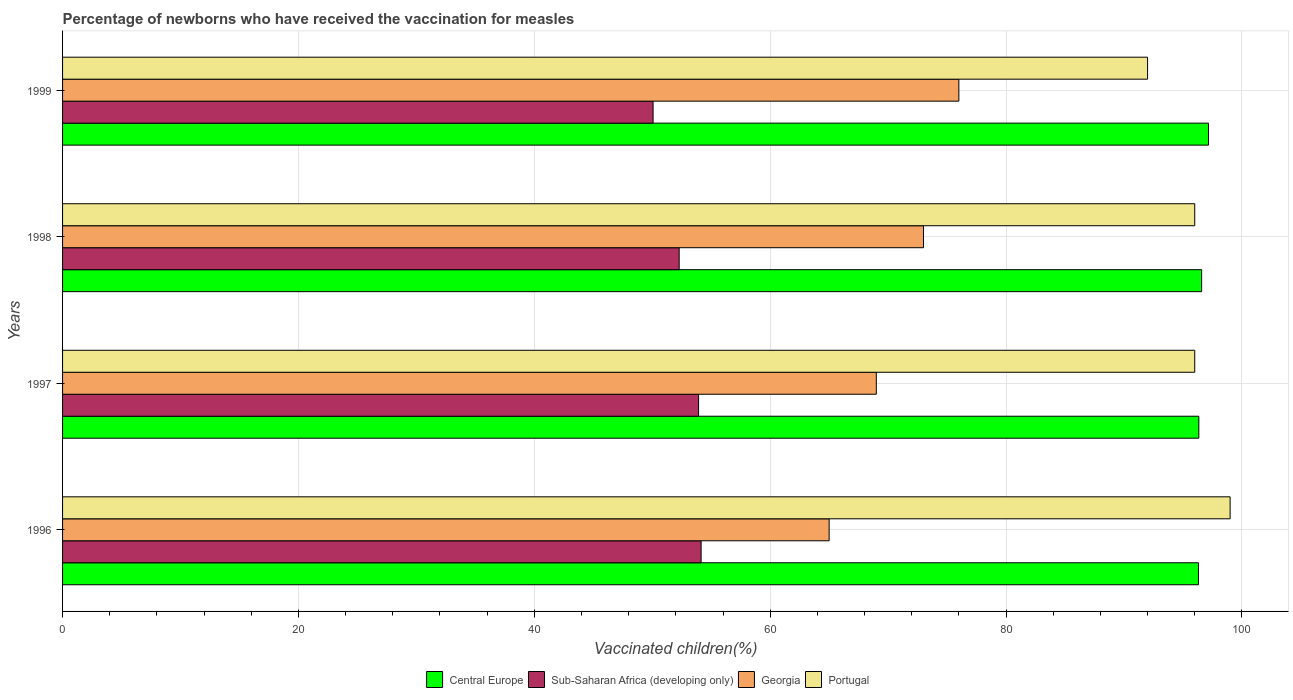How many different coloured bars are there?
Ensure brevity in your answer.  4. How many groups of bars are there?
Ensure brevity in your answer.  4. Are the number of bars on each tick of the Y-axis equal?
Offer a very short reply. Yes. What is the label of the 2nd group of bars from the top?
Your response must be concise. 1998. In how many cases, is the number of bars for a given year not equal to the number of legend labels?
Provide a succinct answer. 0. What is the percentage of vaccinated children in Portugal in 1996?
Give a very brief answer. 99. Across all years, what is the maximum percentage of vaccinated children in Sub-Saharan Africa (developing only)?
Provide a succinct answer. 54.14. Across all years, what is the minimum percentage of vaccinated children in Sub-Saharan Africa (developing only)?
Provide a succinct answer. 50.07. In which year was the percentage of vaccinated children in Sub-Saharan Africa (developing only) maximum?
Provide a succinct answer. 1996. In which year was the percentage of vaccinated children in Central Europe minimum?
Ensure brevity in your answer.  1996. What is the total percentage of vaccinated children in Sub-Saharan Africa (developing only) in the graph?
Offer a terse response. 210.43. What is the difference between the percentage of vaccinated children in Sub-Saharan Africa (developing only) in 1996 and that in 1998?
Provide a short and direct response. 1.86. What is the difference between the percentage of vaccinated children in Sub-Saharan Africa (developing only) in 1996 and the percentage of vaccinated children in Central Europe in 1998?
Your response must be concise. -42.44. What is the average percentage of vaccinated children in Central Europe per year?
Give a very brief answer. 96.6. In the year 1998, what is the difference between the percentage of vaccinated children in Georgia and percentage of vaccinated children in Portugal?
Your answer should be compact. -23. In how many years, is the percentage of vaccinated children in Georgia greater than 76 %?
Offer a very short reply. 0. What is the ratio of the percentage of vaccinated children in Central Europe in 1998 to that in 1999?
Provide a short and direct response. 0.99. Is the difference between the percentage of vaccinated children in Georgia in 1996 and 1998 greater than the difference between the percentage of vaccinated children in Portugal in 1996 and 1998?
Offer a terse response. No. What is the difference between the highest and the lowest percentage of vaccinated children in Portugal?
Ensure brevity in your answer.  7. In how many years, is the percentage of vaccinated children in Portugal greater than the average percentage of vaccinated children in Portugal taken over all years?
Your response must be concise. 3. Is it the case that in every year, the sum of the percentage of vaccinated children in Portugal and percentage of vaccinated children in Sub-Saharan Africa (developing only) is greater than the percentage of vaccinated children in Georgia?
Give a very brief answer. Yes. What is the difference between two consecutive major ticks on the X-axis?
Your answer should be very brief. 20. Are the values on the major ticks of X-axis written in scientific E-notation?
Provide a short and direct response. No. Does the graph contain any zero values?
Keep it short and to the point. No. Does the graph contain grids?
Make the answer very short. Yes. What is the title of the graph?
Offer a very short reply. Percentage of newborns who have received the vaccination for measles. Does "Seychelles" appear as one of the legend labels in the graph?
Ensure brevity in your answer.  No. What is the label or title of the X-axis?
Ensure brevity in your answer.  Vaccinated children(%). What is the label or title of the Y-axis?
Your response must be concise. Years. What is the Vaccinated children(%) of Central Europe in 1996?
Keep it short and to the point. 96.32. What is the Vaccinated children(%) of Sub-Saharan Africa (developing only) in 1996?
Your response must be concise. 54.14. What is the Vaccinated children(%) in Georgia in 1996?
Make the answer very short. 65. What is the Vaccinated children(%) of Central Europe in 1997?
Make the answer very short. 96.35. What is the Vaccinated children(%) in Sub-Saharan Africa (developing only) in 1997?
Keep it short and to the point. 53.93. What is the Vaccinated children(%) in Portugal in 1997?
Ensure brevity in your answer.  96. What is the Vaccinated children(%) of Central Europe in 1998?
Keep it short and to the point. 96.58. What is the Vaccinated children(%) of Sub-Saharan Africa (developing only) in 1998?
Ensure brevity in your answer.  52.28. What is the Vaccinated children(%) in Portugal in 1998?
Your response must be concise. 96. What is the Vaccinated children(%) in Central Europe in 1999?
Keep it short and to the point. 97.17. What is the Vaccinated children(%) in Sub-Saharan Africa (developing only) in 1999?
Keep it short and to the point. 50.07. What is the Vaccinated children(%) of Georgia in 1999?
Your answer should be very brief. 76. What is the Vaccinated children(%) of Portugal in 1999?
Make the answer very short. 92. Across all years, what is the maximum Vaccinated children(%) in Central Europe?
Provide a short and direct response. 97.17. Across all years, what is the maximum Vaccinated children(%) in Sub-Saharan Africa (developing only)?
Your answer should be very brief. 54.14. Across all years, what is the maximum Vaccinated children(%) in Georgia?
Your response must be concise. 76. Across all years, what is the maximum Vaccinated children(%) of Portugal?
Your answer should be compact. 99. Across all years, what is the minimum Vaccinated children(%) of Central Europe?
Provide a short and direct response. 96.32. Across all years, what is the minimum Vaccinated children(%) of Sub-Saharan Africa (developing only)?
Your response must be concise. 50.07. Across all years, what is the minimum Vaccinated children(%) in Portugal?
Make the answer very short. 92. What is the total Vaccinated children(%) in Central Europe in the graph?
Give a very brief answer. 386.41. What is the total Vaccinated children(%) in Sub-Saharan Africa (developing only) in the graph?
Offer a terse response. 210.43. What is the total Vaccinated children(%) in Georgia in the graph?
Offer a very short reply. 283. What is the total Vaccinated children(%) in Portugal in the graph?
Offer a very short reply. 383. What is the difference between the Vaccinated children(%) in Central Europe in 1996 and that in 1997?
Provide a short and direct response. -0.03. What is the difference between the Vaccinated children(%) of Sub-Saharan Africa (developing only) in 1996 and that in 1997?
Make the answer very short. 0.21. What is the difference between the Vaccinated children(%) in Central Europe in 1996 and that in 1998?
Make the answer very short. -0.27. What is the difference between the Vaccinated children(%) in Sub-Saharan Africa (developing only) in 1996 and that in 1998?
Offer a very short reply. 1.86. What is the difference between the Vaccinated children(%) in Georgia in 1996 and that in 1998?
Offer a very short reply. -8. What is the difference between the Vaccinated children(%) of Portugal in 1996 and that in 1998?
Give a very brief answer. 3. What is the difference between the Vaccinated children(%) in Central Europe in 1996 and that in 1999?
Make the answer very short. -0.85. What is the difference between the Vaccinated children(%) in Sub-Saharan Africa (developing only) in 1996 and that in 1999?
Keep it short and to the point. 4.07. What is the difference between the Vaccinated children(%) in Georgia in 1996 and that in 1999?
Provide a succinct answer. -11. What is the difference between the Vaccinated children(%) of Portugal in 1996 and that in 1999?
Offer a very short reply. 7. What is the difference between the Vaccinated children(%) of Central Europe in 1997 and that in 1998?
Give a very brief answer. -0.24. What is the difference between the Vaccinated children(%) of Sub-Saharan Africa (developing only) in 1997 and that in 1998?
Your response must be concise. 1.64. What is the difference between the Vaccinated children(%) of Central Europe in 1997 and that in 1999?
Ensure brevity in your answer.  -0.82. What is the difference between the Vaccinated children(%) in Sub-Saharan Africa (developing only) in 1997 and that in 1999?
Your answer should be very brief. 3.86. What is the difference between the Vaccinated children(%) in Central Europe in 1998 and that in 1999?
Make the answer very short. -0.58. What is the difference between the Vaccinated children(%) in Sub-Saharan Africa (developing only) in 1998 and that in 1999?
Ensure brevity in your answer.  2.21. What is the difference between the Vaccinated children(%) in Portugal in 1998 and that in 1999?
Provide a succinct answer. 4. What is the difference between the Vaccinated children(%) in Central Europe in 1996 and the Vaccinated children(%) in Sub-Saharan Africa (developing only) in 1997?
Give a very brief answer. 42.39. What is the difference between the Vaccinated children(%) of Central Europe in 1996 and the Vaccinated children(%) of Georgia in 1997?
Offer a very short reply. 27.32. What is the difference between the Vaccinated children(%) of Central Europe in 1996 and the Vaccinated children(%) of Portugal in 1997?
Provide a succinct answer. 0.32. What is the difference between the Vaccinated children(%) in Sub-Saharan Africa (developing only) in 1996 and the Vaccinated children(%) in Georgia in 1997?
Offer a very short reply. -14.86. What is the difference between the Vaccinated children(%) in Sub-Saharan Africa (developing only) in 1996 and the Vaccinated children(%) in Portugal in 1997?
Make the answer very short. -41.86. What is the difference between the Vaccinated children(%) in Georgia in 1996 and the Vaccinated children(%) in Portugal in 1997?
Give a very brief answer. -31. What is the difference between the Vaccinated children(%) in Central Europe in 1996 and the Vaccinated children(%) in Sub-Saharan Africa (developing only) in 1998?
Your answer should be very brief. 44.03. What is the difference between the Vaccinated children(%) in Central Europe in 1996 and the Vaccinated children(%) in Georgia in 1998?
Your answer should be very brief. 23.32. What is the difference between the Vaccinated children(%) of Central Europe in 1996 and the Vaccinated children(%) of Portugal in 1998?
Make the answer very short. 0.32. What is the difference between the Vaccinated children(%) of Sub-Saharan Africa (developing only) in 1996 and the Vaccinated children(%) of Georgia in 1998?
Offer a terse response. -18.86. What is the difference between the Vaccinated children(%) of Sub-Saharan Africa (developing only) in 1996 and the Vaccinated children(%) of Portugal in 1998?
Offer a very short reply. -41.86. What is the difference between the Vaccinated children(%) of Georgia in 1996 and the Vaccinated children(%) of Portugal in 1998?
Make the answer very short. -31. What is the difference between the Vaccinated children(%) in Central Europe in 1996 and the Vaccinated children(%) in Sub-Saharan Africa (developing only) in 1999?
Offer a terse response. 46.24. What is the difference between the Vaccinated children(%) of Central Europe in 1996 and the Vaccinated children(%) of Georgia in 1999?
Make the answer very short. 20.32. What is the difference between the Vaccinated children(%) in Central Europe in 1996 and the Vaccinated children(%) in Portugal in 1999?
Offer a terse response. 4.32. What is the difference between the Vaccinated children(%) of Sub-Saharan Africa (developing only) in 1996 and the Vaccinated children(%) of Georgia in 1999?
Provide a succinct answer. -21.86. What is the difference between the Vaccinated children(%) of Sub-Saharan Africa (developing only) in 1996 and the Vaccinated children(%) of Portugal in 1999?
Provide a short and direct response. -37.86. What is the difference between the Vaccinated children(%) in Central Europe in 1997 and the Vaccinated children(%) in Sub-Saharan Africa (developing only) in 1998?
Your response must be concise. 44.06. What is the difference between the Vaccinated children(%) in Central Europe in 1997 and the Vaccinated children(%) in Georgia in 1998?
Your response must be concise. 23.35. What is the difference between the Vaccinated children(%) in Central Europe in 1997 and the Vaccinated children(%) in Portugal in 1998?
Offer a terse response. 0.35. What is the difference between the Vaccinated children(%) in Sub-Saharan Africa (developing only) in 1997 and the Vaccinated children(%) in Georgia in 1998?
Offer a terse response. -19.07. What is the difference between the Vaccinated children(%) of Sub-Saharan Africa (developing only) in 1997 and the Vaccinated children(%) of Portugal in 1998?
Provide a short and direct response. -42.07. What is the difference between the Vaccinated children(%) of Central Europe in 1997 and the Vaccinated children(%) of Sub-Saharan Africa (developing only) in 1999?
Your answer should be very brief. 46.27. What is the difference between the Vaccinated children(%) of Central Europe in 1997 and the Vaccinated children(%) of Georgia in 1999?
Provide a succinct answer. 20.35. What is the difference between the Vaccinated children(%) of Central Europe in 1997 and the Vaccinated children(%) of Portugal in 1999?
Provide a succinct answer. 4.35. What is the difference between the Vaccinated children(%) of Sub-Saharan Africa (developing only) in 1997 and the Vaccinated children(%) of Georgia in 1999?
Your response must be concise. -22.07. What is the difference between the Vaccinated children(%) of Sub-Saharan Africa (developing only) in 1997 and the Vaccinated children(%) of Portugal in 1999?
Provide a succinct answer. -38.07. What is the difference between the Vaccinated children(%) in Central Europe in 1998 and the Vaccinated children(%) in Sub-Saharan Africa (developing only) in 1999?
Provide a succinct answer. 46.51. What is the difference between the Vaccinated children(%) in Central Europe in 1998 and the Vaccinated children(%) in Georgia in 1999?
Provide a succinct answer. 20.58. What is the difference between the Vaccinated children(%) of Central Europe in 1998 and the Vaccinated children(%) of Portugal in 1999?
Ensure brevity in your answer.  4.58. What is the difference between the Vaccinated children(%) in Sub-Saharan Africa (developing only) in 1998 and the Vaccinated children(%) in Georgia in 1999?
Your answer should be very brief. -23.72. What is the difference between the Vaccinated children(%) in Sub-Saharan Africa (developing only) in 1998 and the Vaccinated children(%) in Portugal in 1999?
Provide a succinct answer. -39.72. What is the average Vaccinated children(%) in Central Europe per year?
Your response must be concise. 96.6. What is the average Vaccinated children(%) in Sub-Saharan Africa (developing only) per year?
Your response must be concise. 52.61. What is the average Vaccinated children(%) of Georgia per year?
Provide a short and direct response. 70.75. What is the average Vaccinated children(%) in Portugal per year?
Offer a terse response. 95.75. In the year 1996, what is the difference between the Vaccinated children(%) in Central Europe and Vaccinated children(%) in Sub-Saharan Africa (developing only)?
Give a very brief answer. 42.17. In the year 1996, what is the difference between the Vaccinated children(%) of Central Europe and Vaccinated children(%) of Georgia?
Your response must be concise. 31.32. In the year 1996, what is the difference between the Vaccinated children(%) in Central Europe and Vaccinated children(%) in Portugal?
Provide a short and direct response. -2.68. In the year 1996, what is the difference between the Vaccinated children(%) of Sub-Saharan Africa (developing only) and Vaccinated children(%) of Georgia?
Provide a short and direct response. -10.86. In the year 1996, what is the difference between the Vaccinated children(%) of Sub-Saharan Africa (developing only) and Vaccinated children(%) of Portugal?
Make the answer very short. -44.86. In the year 1996, what is the difference between the Vaccinated children(%) of Georgia and Vaccinated children(%) of Portugal?
Your response must be concise. -34. In the year 1997, what is the difference between the Vaccinated children(%) in Central Europe and Vaccinated children(%) in Sub-Saharan Africa (developing only)?
Offer a terse response. 42.42. In the year 1997, what is the difference between the Vaccinated children(%) of Central Europe and Vaccinated children(%) of Georgia?
Keep it short and to the point. 27.35. In the year 1997, what is the difference between the Vaccinated children(%) in Central Europe and Vaccinated children(%) in Portugal?
Make the answer very short. 0.35. In the year 1997, what is the difference between the Vaccinated children(%) of Sub-Saharan Africa (developing only) and Vaccinated children(%) of Georgia?
Your answer should be compact. -15.07. In the year 1997, what is the difference between the Vaccinated children(%) of Sub-Saharan Africa (developing only) and Vaccinated children(%) of Portugal?
Provide a succinct answer. -42.07. In the year 1998, what is the difference between the Vaccinated children(%) in Central Europe and Vaccinated children(%) in Sub-Saharan Africa (developing only)?
Provide a short and direct response. 44.3. In the year 1998, what is the difference between the Vaccinated children(%) of Central Europe and Vaccinated children(%) of Georgia?
Your response must be concise. 23.58. In the year 1998, what is the difference between the Vaccinated children(%) in Central Europe and Vaccinated children(%) in Portugal?
Give a very brief answer. 0.58. In the year 1998, what is the difference between the Vaccinated children(%) of Sub-Saharan Africa (developing only) and Vaccinated children(%) of Georgia?
Provide a short and direct response. -20.72. In the year 1998, what is the difference between the Vaccinated children(%) of Sub-Saharan Africa (developing only) and Vaccinated children(%) of Portugal?
Your answer should be very brief. -43.72. In the year 1998, what is the difference between the Vaccinated children(%) of Georgia and Vaccinated children(%) of Portugal?
Ensure brevity in your answer.  -23. In the year 1999, what is the difference between the Vaccinated children(%) in Central Europe and Vaccinated children(%) in Sub-Saharan Africa (developing only)?
Provide a succinct answer. 47.09. In the year 1999, what is the difference between the Vaccinated children(%) of Central Europe and Vaccinated children(%) of Georgia?
Offer a very short reply. 21.17. In the year 1999, what is the difference between the Vaccinated children(%) in Central Europe and Vaccinated children(%) in Portugal?
Make the answer very short. 5.17. In the year 1999, what is the difference between the Vaccinated children(%) in Sub-Saharan Africa (developing only) and Vaccinated children(%) in Georgia?
Your response must be concise. -25.93. In the year 1999, what is the difference between the Vaccinated children(%) in Sub-Saharan Africa (developing only) and Vaccinated children(%) in Portugal?
Your response must be concise. -41.93. What is the ratio of the Vaccinated children(%) in Sub-Saharan Africa (developing only) in 1996 to that in 1997?
Offer a very short reply. 1. What is the ratio of the Vaccinated children(%) of Georgia in 1996 to that in 1997?
Your response must be concise. 0.94. What is the ratio of the Vaccinated children(%) in Portugal in 1996 to that in 1997?
Keep it short and to the point. 1.03. What is the ratio of the Vaccinated children(%) in Sub-Saharan Africa (developing only) in 1996 to that in 1998?
Give a very brief answer. 1.04. What is the ratio of the Vaccinated children(%) of Georgia in 1996 to that in 1998?
Ensure brevity in your answer.  0.89. What is the ratio of the Vaccinated children(%) in Portugal in 1996 to that in 1998?
Your answer should be compact. 1.03. What is the ratio of the Vaccinated children(%) in Sub-Saharan Africa (developing only) in 1996 to that in 1999?
Your answer should be very brief. 1.08. What is the ratio of the Vaccinated children(%) in Georgia in 1996 to that in 1999?
Keep it short and to the point. 0.86. What is the ratio of the Vaccinated children(%) in Portugal in 1996 to that in 1999?
Provide a short and direct response. 1.08. What is the ratio of the Vaccinated children(%) of Sub-Saharan Africa (developing only) in 1997 to that in 1998?
Ensure brevity in your answer.  1.03. What is the ratio of the Vaccinated children(%) of Georgia in 1997 to that in 1998?
Your answer should be very brief. 0.95. What is the ratio of the Vaccinated children(%) in Central Europe in 1997 to that in 1999?
Your response must be concise. 0.99. What is the ratio of the Vaccinated children(%) of Sub-Saharan Africa (developing only) in 1997 to that in 1999?
Ensure brevity in your answer.  1.08. What is the ratio of the Vaccinated children(%) of Georgia in 1997 to that in 1999?
Your answer should be very brief. 0.91. What is the ratio of the Vaccinated children(%) of Portugal in 1997 to that in 1999?
Provide a succinct answer. 1.04. What is the ratio of the Vaccinated children(%) in Sub-Saharan Africa (developing only) in 1998 to that in 1999?
Your answer should be compact. 1.04. What is the ratio of the Vaccinated children(%) in Georgia in 1998 to that in 1999?
Make the answer very short. 0.96. What is the ratio of the Vaccinated children(%) in Portugal in 1998 to that in 1999?
Give a very brief answer. 1.04. What is the difference between the highest and the second highest Vaccinated children(%) of Central Europe?
Provide a succinct answer. 0.58. What is the difference between the highest and the second highest Vaccinated children(%) in Sub-Saharan Africa (developing only)?
Provide a short and direct response. 0.21. What is the difference between the highest and the second highest Vaccinated children(%) of Portugal?
Your answer should be very brief. 3. What is the difference between the highest and the lowest Vaccinated children(%) in Central Europe?
Your response must be concise. 0.85. What is the difference between the highest and the lowest Vaccinated children(%) in Sub-Saharan Africa (developing only)?
Make the answer very short. 4.07. What is the difference between the highest and the lowest Vaccinated children(%) of Georgia?
Make the answer very short. 11. What is the difference between the highest and the lowest Vaccinated children(%) of Portugal?
Ensure brevity in your answer.  7. 